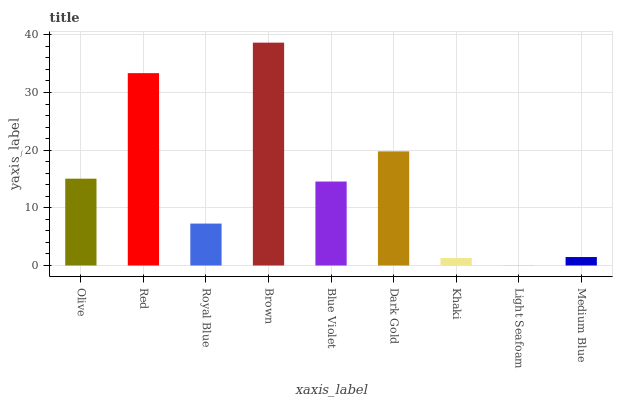Is Light Seafoam the minimum?
Answer yes or no. Yes. Is Brown the maximum?
Answer yes or no. Yes. Is Red the minimum?
Answer yes or no. No. Is Red the maximum?
Answer yes or no. No. Is Red greater than Olive?
Answer yes or no. Yes. Is Olive less than Red?
Answer yes or no. Yes. Is Olive greater than Red?
Answer yes or no. No. Is Red less than Olive?
Answer yes or no. No. Is Blue Violet the high median?
Answer yes or no. Yes. Is Blue Violet the low median?
Answer yes or no. Yes. Is Royal Blue the high median?
Answer yes or no. No. Is Khaki the low median?
Answer yes or no. No. 